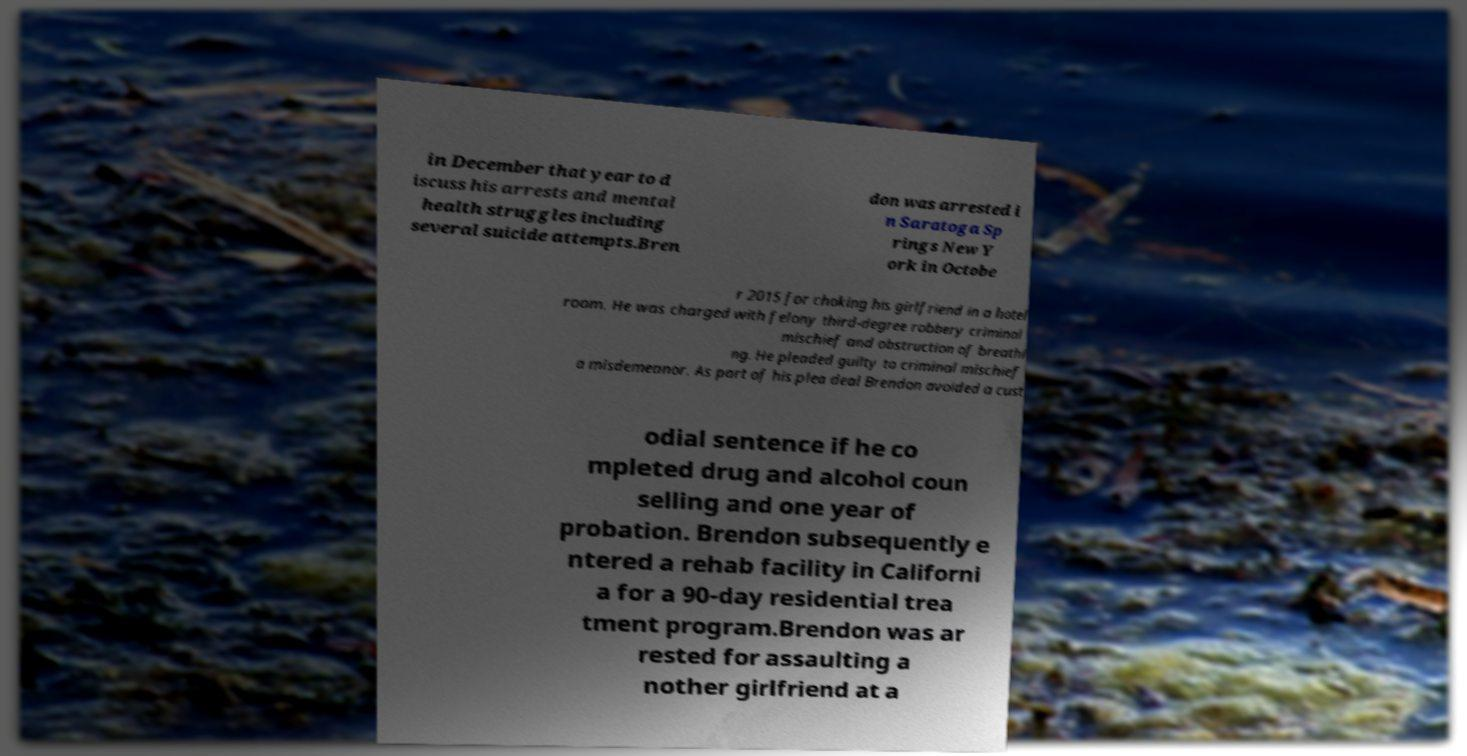What messages or text are displayed in this image? I need them in a readable, typed format. in December that year to d iscuss his arrests and mental health struggles including several suicide attempts.Bren don was arrested i n Saratoga Sp rings New Y ork in Octobe r 2015 for choking his girlfriend in a hotel room. He was charged with felony third-degree robbery criminal mischief and obstruction of breathi ng. He pleaded guilty to criminal mischief a misdemeanor. As part of his plea deal Brendon avoided a cust odial sentence if he co mpleted drug and alcohol coun selling and one year of probation. Brendon subsequently e ntered a rehab facility in Californi a for a 90-day residential trea tment program.Brendon was ar rested for assaulting a nother girlfriend at a 